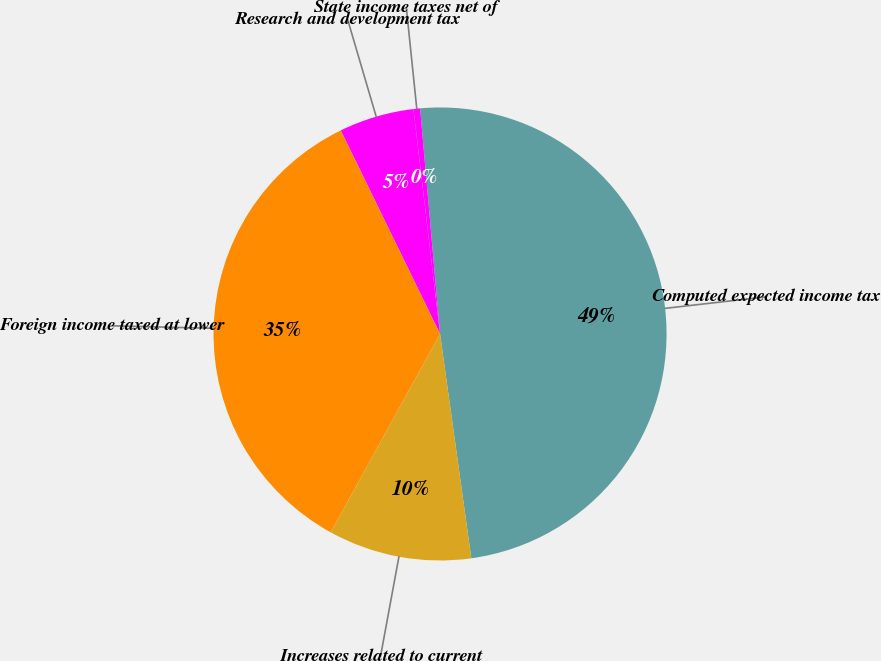<chart> <loc_0><loc_0><loc_500><loc_500><pie_chart><fcel>Computed expected income tax<fcel>State income taxes net of<fcel>Research and development tax<fcel>Foreign income taxed at lower<fcel>Increases related to current<nl><fcel>49.2%<fcel>0.47%<fcel>5.35%<fcel>34.76%<fcel>10.22%<nl></chart> 